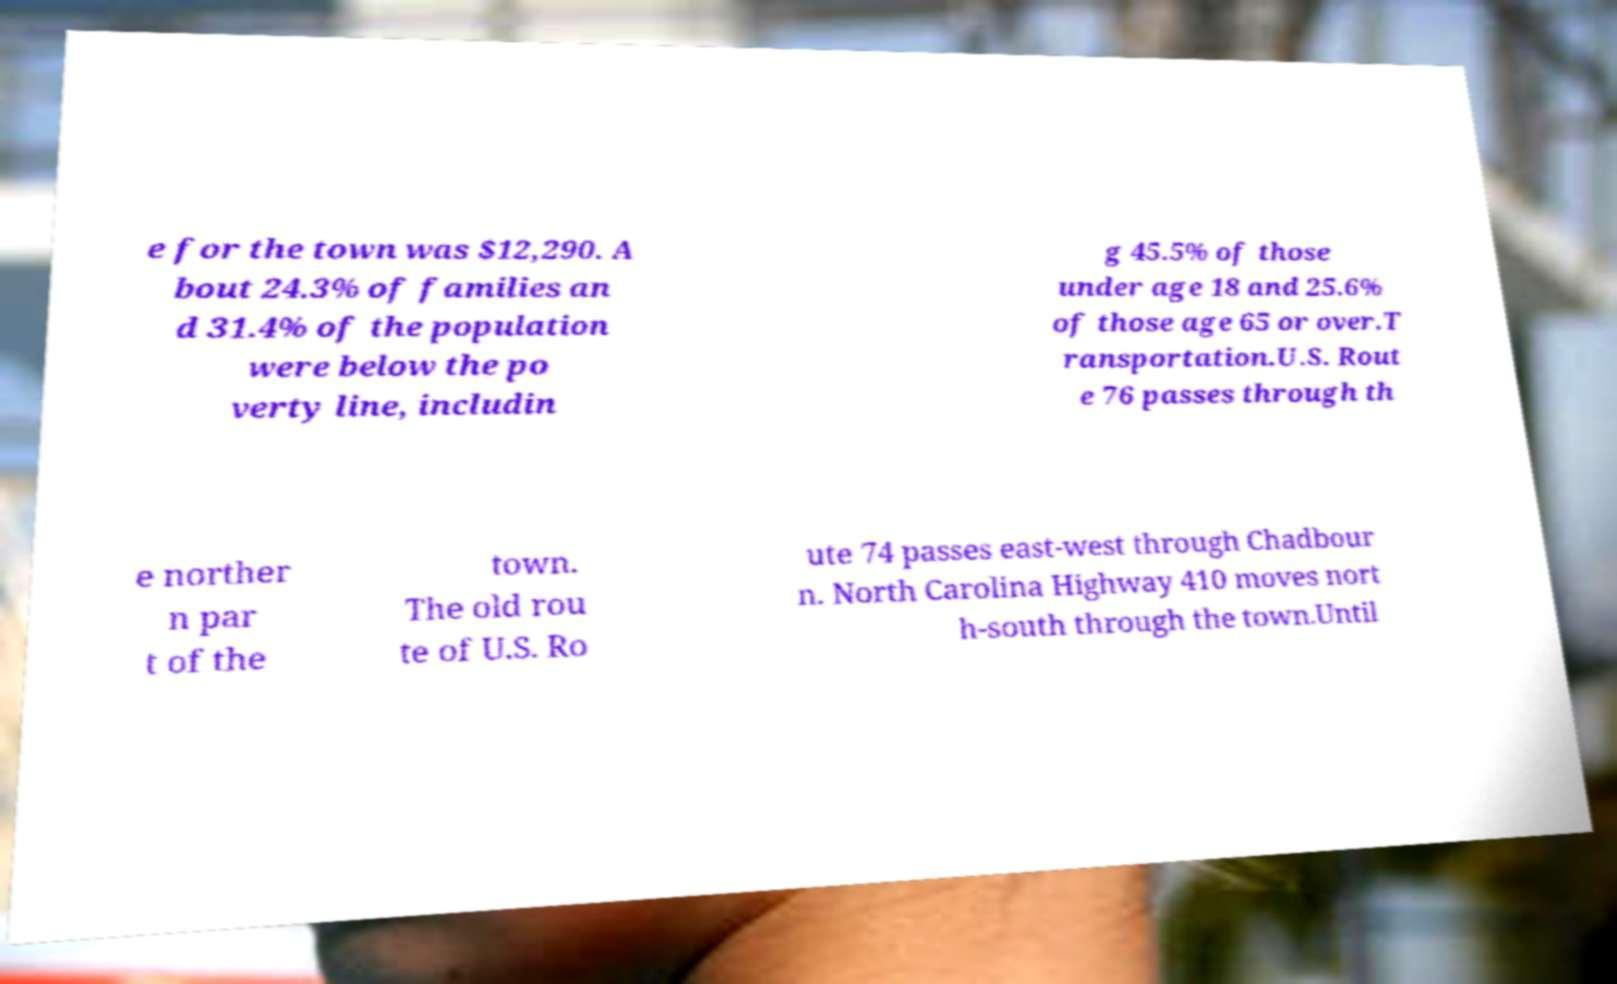Please identify and transcribe the text found in this image. e for the town was $12,290. A bout 24.3% of families an d 31.4% of the population were below the po verty line, includin g 45.5% of those under age 18 and 25.6% of those age 65 or over.T ransportation.U.S. Rout e 76 passes through th e norther n par t of the town. The old rou te of U.S. Ro ute 74 passes east-west through Chadbour n. North Carolina Highway 410 moves nort h-south through the town.Until 